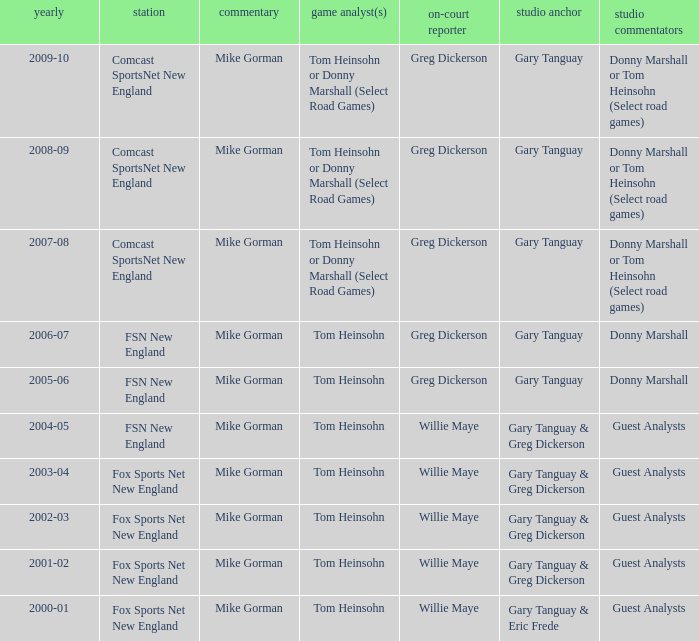WHich Color commentatorhas a Studio host of gary tanguay & eric frede? Tom Heinsohn. Could you help me parse every detail presented in this table? {'header': ['yearly', 'station', 'commentary', 'game analyst(s)', 'on-court reporter', 'studio anchor', 'studio commentators'], 'rows': [['2009-10', 'Comcast SportsNet New England', 'Mike Gorman', 'Tom Heinsohn or Donny Marshall (Select Road Games)', 'Greg Dickerson', 'Gary Tanguay', 'Donny Marshall or Tom Heinsohn (Select road games)'], ['2008-09', 'Comcast SportsNet New England', 'Mike Gorman', 'Tom Heinsohn or Donny Marshall (Select Road Games)', 'Greg Dickerson', 'Gary Tanguay', 'Donny Marshall or Tom Heinsohn (Select road games)'], ['2007-08', 'Comcast SportsNet New England', 'Mike Gorman', 'Tom Heinsohn or Donny Marshall (Select Road Games)', 'Greg Dickerson', 'Gary Tanguay', 'Donny Marshall or Tom Heinsohn (Select road games)'], ['2006-07', 'FSN New England', 'Mike Gorman', 'Tom Heinsohn', 'Greg Dickerson', 'Gary Tanguay', 'Donny Marshall'], ['2005-06', 'FSN New England', 'Mike Gorman', 'Tom Heinsohn', 'Greg Dickerson', 'Gary Tanguay', 'Donny Marshall'], ['2004-05', 'FSN New England', 'Mike Gorman', 'Tom Heinsohn', 'Willie Maye', 'Gary Tanguay & Greg Dickerson', 'Guest Analysts'], ['2003-04', 'Fox Sports Net New England', 'Mike Gorman', 'Tom Heinsohn', 'Willie Maye', 'Gary Tanguay & Greg Dickerson', 'Guest Analysts'], ['2002-03', 'Fox Sports Net New England', 'Mike Gorman', 'Tom Heinsohn', 'Willie Maye', 'Gary Tanguay & Greg Dickerson', 'Guest Analysts'], ['2001-02', 'Fox Sports Net New England', 'Mike Gorman', 'Tom Heinsohn', 'Willie Maye', 'Gary Tanguay & Greg Dickerson', 'Guest Analysts'], ['2000-01', 'Fox Sports Net New England', 'Mike Gorman', 'Tom Heinsohn', 'Willie Maye', 'Gary Tanguay & Eric Frede', 'Guest Analysts']]} 